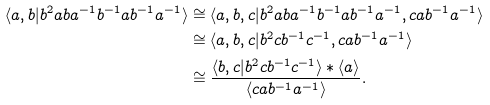Convert formula to latex. <formula><loc_0><loc_0><loc_500><loc_500>\langle a , b | b ^ { 2 } a b a ^ { - 1 } b ^ { - 1 } a b ^ { - 1 } a ^ { - 1 } \rangle & \cong \langle a , b , c | b ^ { 2 } a b a ^ { - 1 } b ^ { - 1 } a b ^ { - 1 } a ^ { - 1 } , c a b ^ { - 1 } a ^ { - 1 } \rangle \\ & \cong \langle a , b , c | b ^ { 2 } c b ^ { - 1 } c ^ { - 1 } , c a b ^ { - 1 } a ^ { - 1 } \rangle \\ & \cong \frac { \langle b , c | b ^ { 2 } c b ^ { - 1 } c ^ { - 1 } \rangle * \langle a \rangle } { \langle c a b ^ { - 1 } a ^ { - 1 } \rangle } .</formula> 